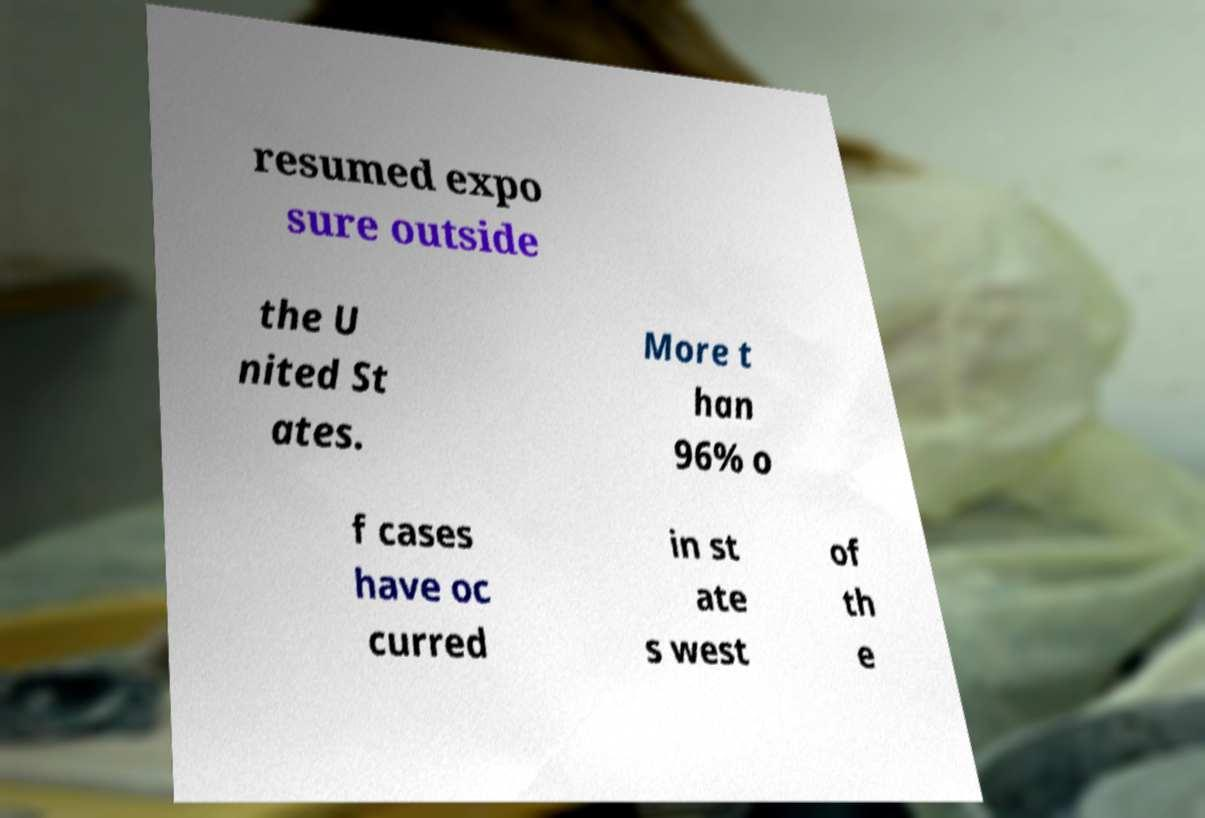Please read and relay the text visible in this image. What does it say? resumed expo sure outside the U nited St ates. More t han 96% o f cases have oc curred in st ate s west of th e 